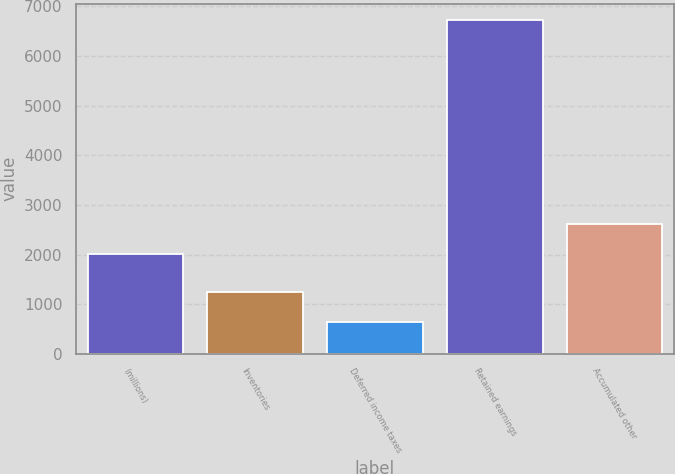Convert chart. <chart><loc_0><loc_0><loc_500><loc_500><bar_chart><fcel>(millions)<fcel>Inventories<fcel>Deferred income taxes<fcel>Retained earnings<fcel>Accumulated other<nl><fcel>2011<fcel>1245.4<fcel>637<fcel>6721<fcel>2619.4<nl></chart> 